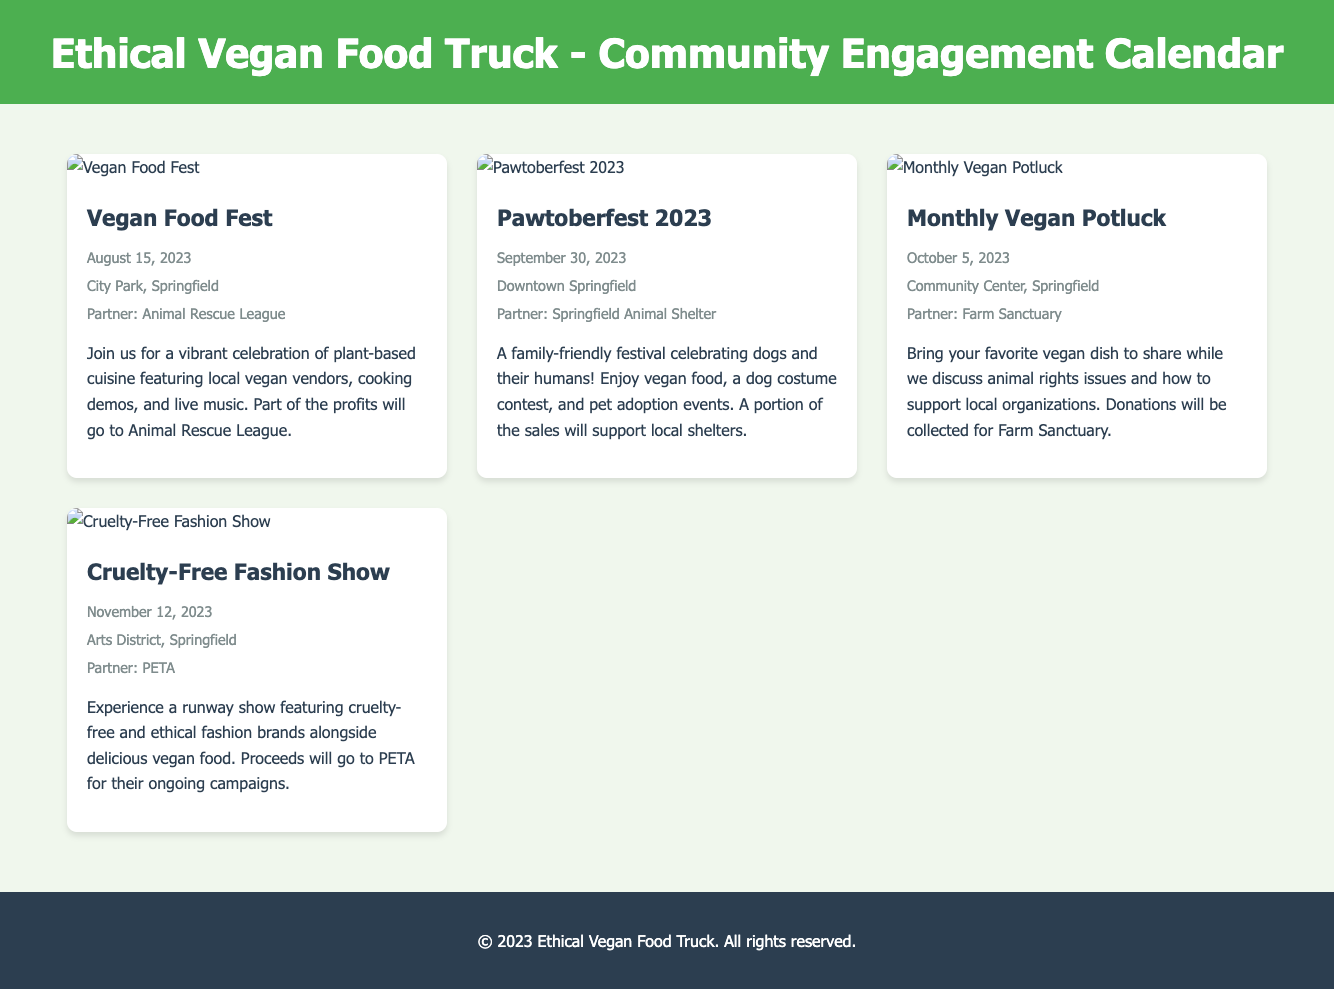What is the name of the first event? The name of the first event listed in the document is found in the event card's details.
Answer: Vegan Food Fest When is the Pawtoberfest 2023 event? The date for Pawtoberfest 2023 is provided next to the event name in its details.
Answer: September 30, 2023 Where will the Monthly Vegan Potluck take place? The location for the Monthly Vegan Potluck is specified in the event details under the event name.
Answer: Community Center, Springfield Which partner organization is involved in the Cruelty-Free Fashion Show? The partner organization for the Cruelty-Free Fashion Show is mentioned in the event card's details.
Answer: PETA What type of event is the Vegan Food Fest? The description of the Vegan Food Fest provides information on the nature of the event.
Answer: Celebration of plant-based cuisine What is the main focus of the Monthly Vegan Potluck? The focus of the Monthly Vegan Potluck is clarified in its event description regarding the discussion topics.
Answer: Animal rights issues How many events are listed in total? The total number of events is calculated by counting the event cards in the document.
Answer: Four What type of entertainment will be featured at the Vegan Food Fest? The type of entertainment at the Vegan Food Fest is described in the event details.
Answer: Live music Which organization will benefit from the proceeds of the Cruelty-Free Fashion Show? The organization benefiting from the fashion show proceeds is mentioned in the event description.
Answer: PETA 